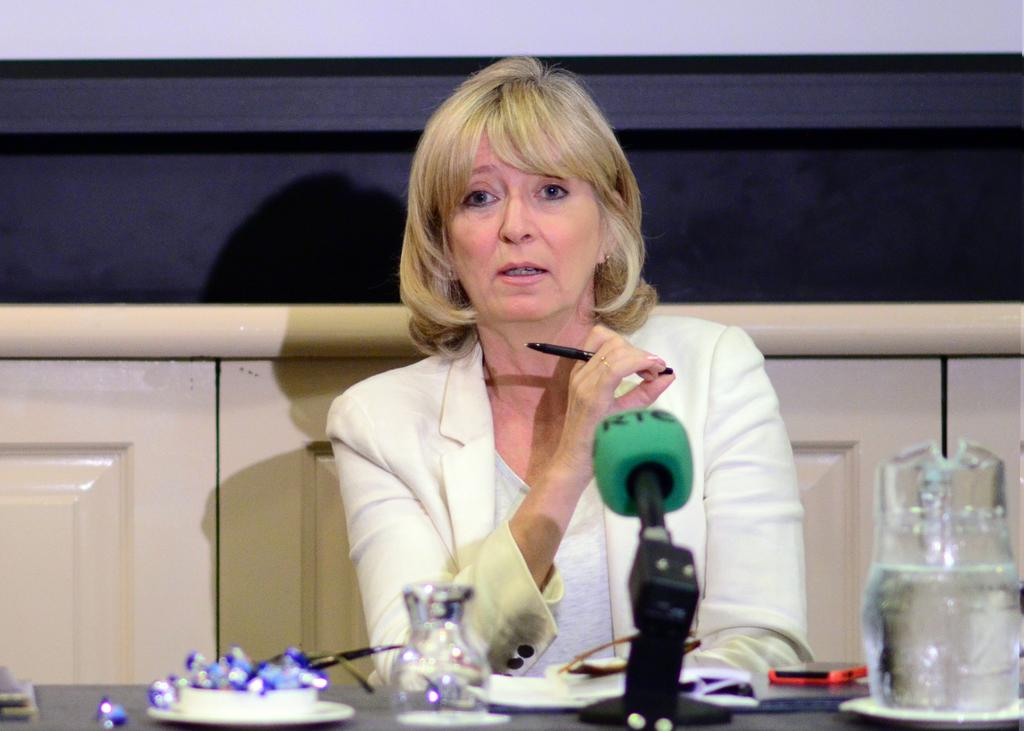<image>
Render a clear and concise summary of the photo. RTC is printed on a microphone on a table in front of a woman. 